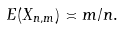<formula> <loc_0><loc_0><loc_500><loc_500>E ( X _ { n , m } ) \asymp m / n .</formula> 